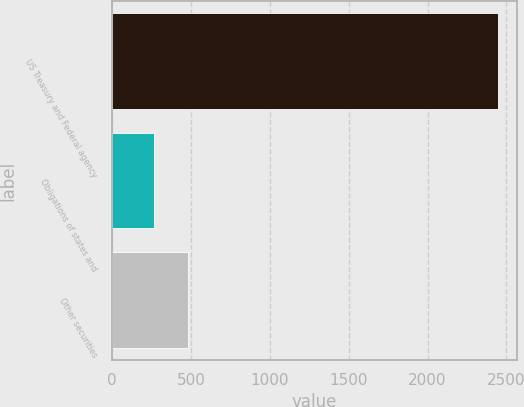Convert chart. <chart><loc_0><loc_0><loc_500><loc_500><bar_chart><fcel>US Treasury and Federal agency<fcel>Obligations of states and<fcel>Other securities<nl><fcel>2447<fcel>264<fcel>482.3<nl></chart> 